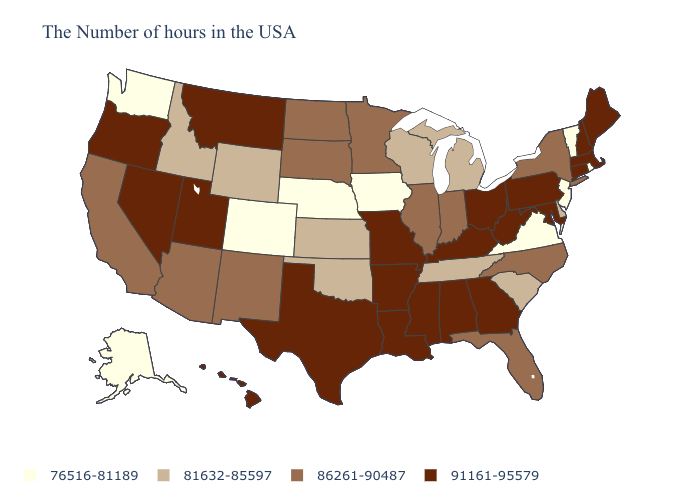Does the map have missing data?
Concise answer only. No. Name the states that have a value in the range 81632-85597?
Give a very brief answer. Delaware, South Carolina, Michigan, Tennessee, Wisconsin, Kansas, Oklahoma, Wyoming, Idaho. Name the states that have a value in the range 91161-95579?
Answer briefly. Maine, Massachusetts, New Hampshire, Connecticut, Maryland, Pennsylvania, West Virginia, Ohio, Georgia, Kentucky, Alabama, Mississippi, Louisiana, Missouri, Arkansas, Texas, Utah, Montana, Nevada, Oregon, Hawaii. What is the lowest value in the USA?
Short answer required. 76516-81189. Name the states that have a value in the range 76516-81189?
Concise answer only. Rhode Island, Vermont, New Jersey, Virginia, Iowa, Nebraska, Colorado, Washington, Alaska. Name the states that have a value in the range 91161-95579?
Quick response, please. Maine, Massachusetts, New Hampshire, Connecticut, Maryland, Pennsylvania, West Virginia, Ohio, Georgia, Kentucky, Alabama, Mississippi, Louisiana, Missouri, Arkansas, Texas, Utah, Montana, Nevada, Oregon, Hawaii. Name the states that have a value in the range 76516-81189?
Short answer required. Rhode Island, Vermont, New Jersey, Virginia, Iowa, Nebraska, Colorado, Washington, Alaska. What is the highest value in states that border Michigan?
Short answer required. 91161-95579. Does Connecticut have a higher value than Idaho?
Give a very brief answer. Yes. What is the highest value in the USA?
Be succinct. 91161-95579. Name the states that have a value in the range 76516-81189?
Short answer required. Rhode Island, Vermont, New Jersey, Virginia, Iowa, Nebraska, Colorado, Washington, Alaska. Name the states that have a value in the range 86261-90487?
Give a very brief answer. New York, North Carolina, Florida, Indiana, Illinois, Minnesota, South Dakota, North Dakota, New Mexico, Arizona, California. What is the highest value in the MidWest ?
Be succinct. 91161-95579. Does North Dakota have the same value as Massachusetts?
Concise answer only. No. What is the value of California?
Give a very brief answer. 86261-90487. 